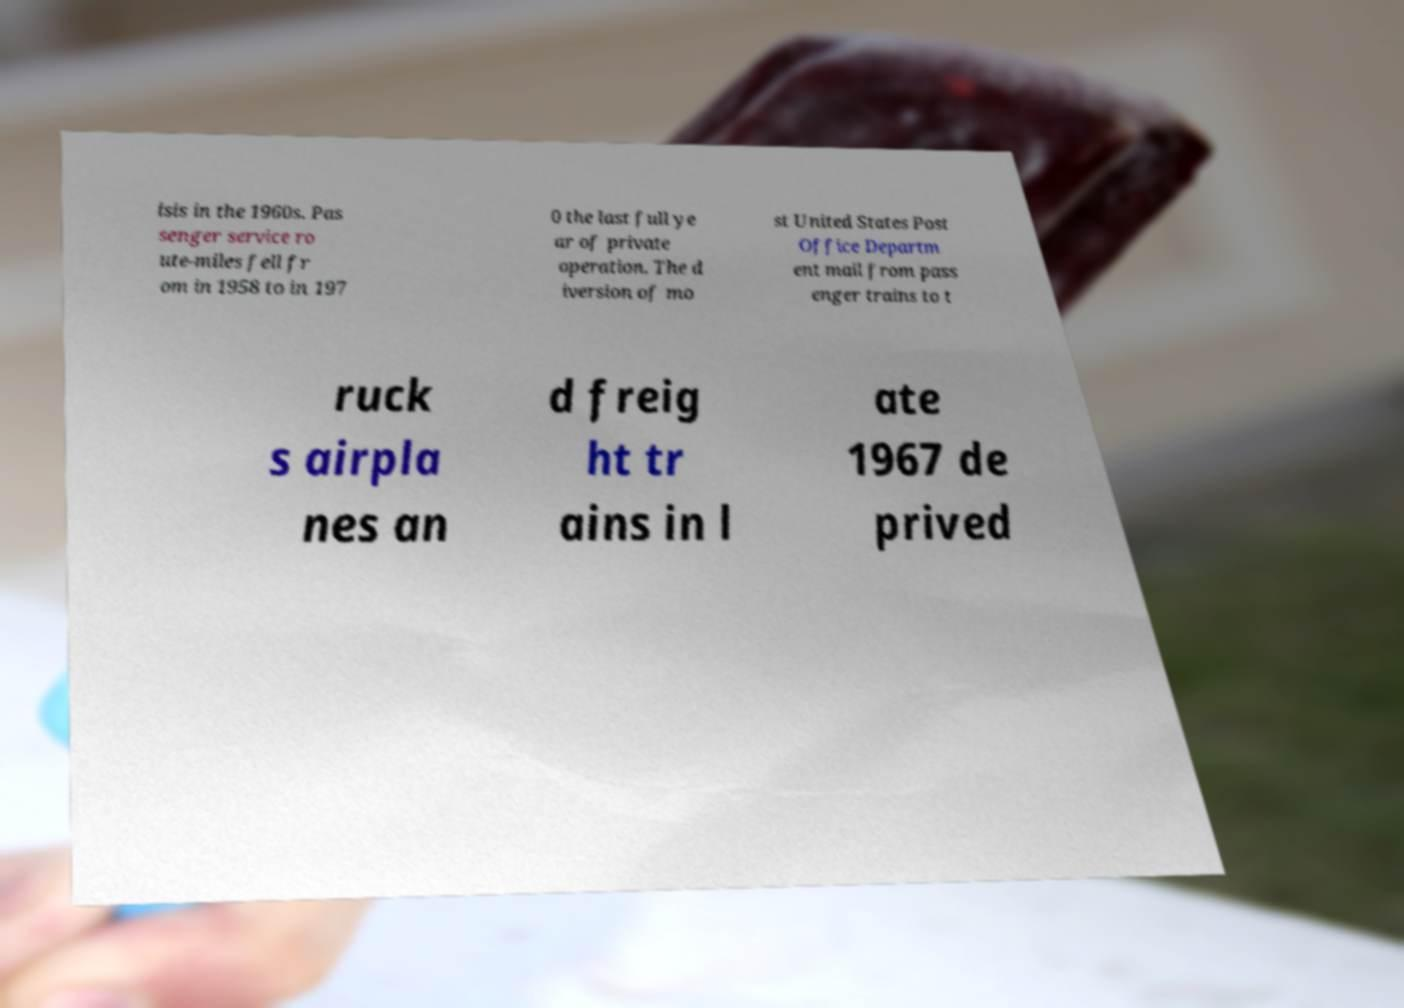For documentation purposes, I need the text within this image transcribed. Could you provide that? isis in the 1960s. Pas senger service ro ute-miles fell fr om in 1958 to in 197 0 the last full ye ar of private operation. The d iversion of mo st United States Post Office Departm ent mail from pass enger trains to t ruck s airpla nes an d freig ht tr ains in l ate 1967 de prived 